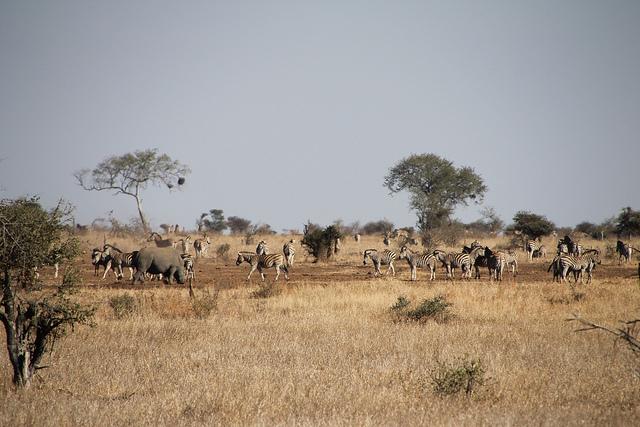What heard of animal is in the distance?
Keep it brief. Zebra. Where are the zebra?
Concise answer only. Field. Is this animal in the wild?
Give a very brief answer. Yes. How many zebras are there in this photo?
Answer briefly. 20. What are the animals in the field?
Answer briefly. Zebras and rhinos. Is the grass living or dead?
Be succinct. Dead. How many animals?
Quick response, please. 40. What continent do these animals live on?
Short answer required. Africa. Is the herd of animals grazing in the grass?
Quick response, please. Yes. Are there lots of clouds in the sky?
Answer briefly. No. Is there only one kind of animal in this picture?
Keep it brief. No. 